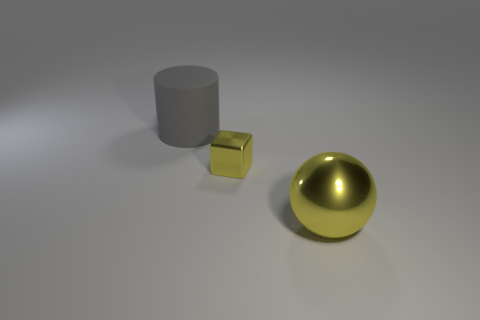Can you describe the lighting in this scene? The scene is softly lit from above, casting gentle shadows to the right of the objects. The light source appears to be positioned in front of the objects, highlighting the front faces of the cylinder and cube, and creating a bright reflection on the top of the sphere. The lighting contributes to a calm and serene atmosphere. 